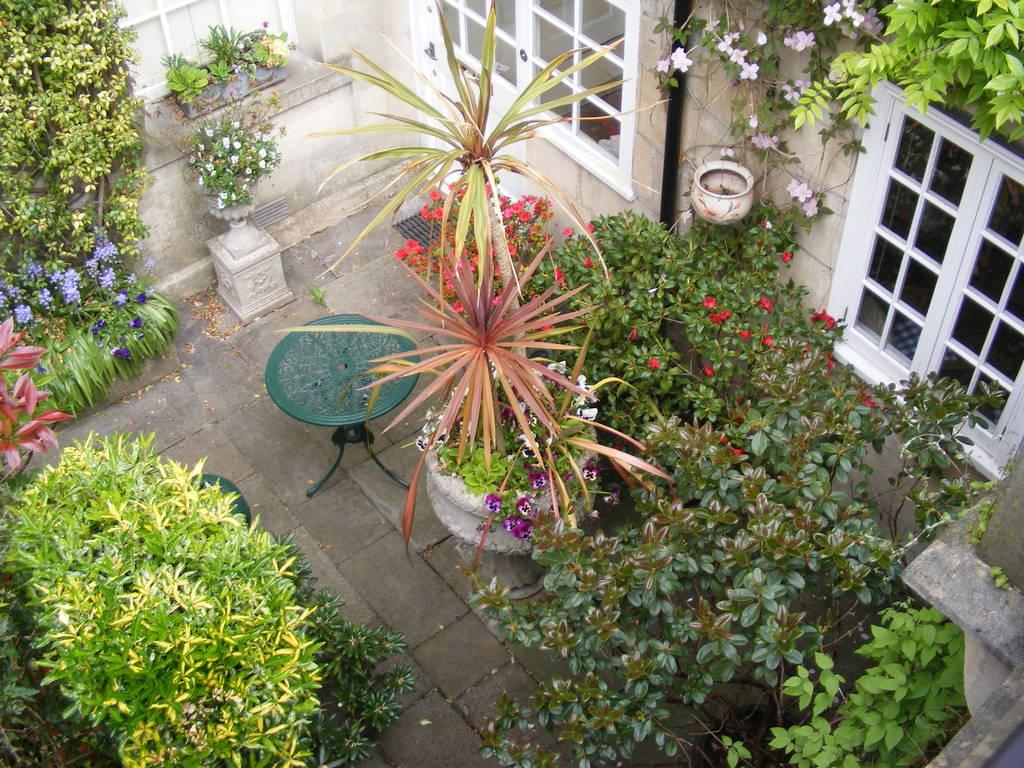What type of openings can be seen in the image? There are windows in the image. What type of vegetation is present in the image? Creeper plants and houseplants are visible in the image. What type of furniture is in the image? There is a side table in the image. What type of landscape feature is present in the image? Bushes are present in the image. What type of debris is visible in the image? Shredded leaves are visible in the image. What type of structure is depicted in the image? There are walls in the image. What type of organization is hosting the book show in the image? There is no organization or book show present in the image. What type of book is being displayed on the side table in the image? There is no book present in the image. 